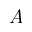<formula> <loc_0><loc_0><loc_500><loc_500>A</formula> 